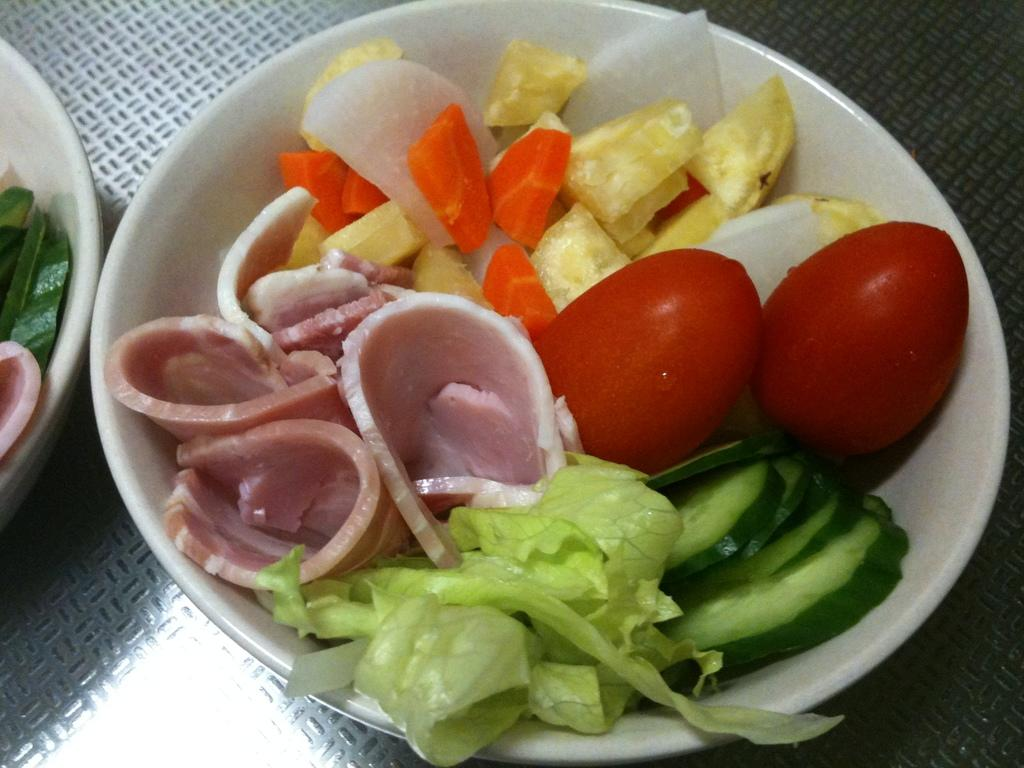What is in the bowl that is visible in the image? There is a food item in the bowl. What type of vegetables can be seen in the image? There are carrots, onions, and tomatoes in the image. Where is the bowl located in the image? The bowl is on the table. What type of grape is being used as a beast to pull the trains in the image? There are no grapes, beasts, or trains present in the image. 